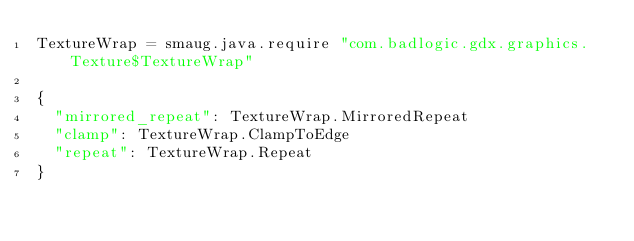<code> <loc_0><loc_0><loc_500><loc_500><_MoonScript_>TextureWrap = smaug.java.require "com.badlogic.gdx.graphics.Texture$TextureWrap"

{
  "mirrored_repeat": TextureWrap.MirroredRepeat
  "clamp": TextureWrap.ClampToEdge
  "repeat": TextureWrap.Repeat
}
</code> 